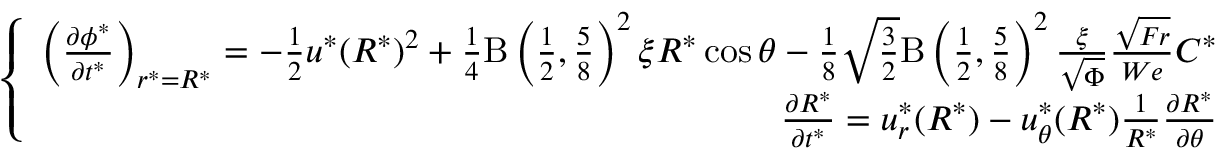Convert formula to latex. <formula><loc_0><loc_0><loc_500><loc_500>\left \{ \begin{array} { r } { \left ( \frac { \partial \phi ^ { * } } { \partial t ^ { * } } \right ) _ { r ^ { * } = R ^ { * } } = - \frac { 1 } { 2 } u ^ { * } ( R ^ { * } ) ^ { 2 } + \frac { 1 } { 4 } B \left ( \frac { 1 } { 2 } , \frac { 5 } { 8 } \right ) ^ { 2 } \xi R ^ { * } \cos \theta - \frac { 1 } { 8 } \sqrt { \frac { 3 } { 2 } } B \left ( \frac { 1 } { 2 } , \frac { 5 } { 8 } \right ) ^ { 2 } \frac { \xi } { \sqrt { \Phi } } \frac { \sqrt { F r } } { W e } C ^ { * } } \\ { \frac { \partial R ^ { * } } { \partial t ^ { * } } = u _ { r } ^ { * } ( R ^ { * } ) - u _ { \theta } ^ { * } ( R ^ { * } ) \frac { 1 } { R ^ { * } } \frac { \partial R ^ { * } } { \partial \theta } } \end{array} ,</formula> 